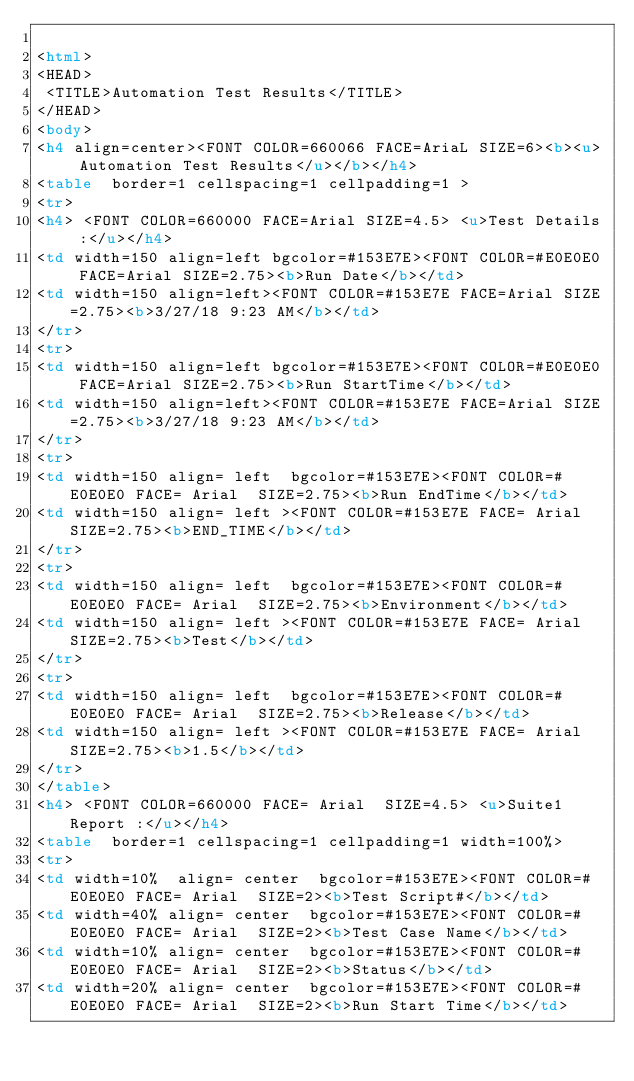Convert code to text. <code><loc_0><loc_0><loc_500><loc_500><_HTML_>
<html>
<HEAD>
 <TITLE>Automation Test Results</TITLE>
</HEAD>
<body>
<h4 align=center><FONT COLOR=660066 FACE=AriaL SIZE=6><b><u> Automation Test Results</u></b></h4>
<table  border=1 cellspacing=1 cellpadding=1 >
<tr>
<h4> <FONT COLOR=660000 FACE=Arial SIZE=4.5> <u>Test Details :</u></h4>
<td width=150 align=left bgcolor=#153E7E><FONT COLOR=#E0E0E0 FACE=Arial SIZE=2.75><b>Run Date</b></td>
<td width=150 align=left><FONT COLOR=#153E7E FACE=Arial SIZE=2.75><b>3/27/18 9:23 AM</b></td>
</tr>
<tr>
<td width=150 align=left bgcolor=#153E7E><FONT COLOR=#E0E0E0 FACE=Arial SIZE=2.75><b>Run StartTime</b></td>
<td width=150 align=left><FONT COLOR=#153E7E FACE=Arial SIZE=2.75><b>3/27/18 9:23 AM</b></td>
</tr>
<tr>
<td width=150 align= left  bgcolor=#153E7E><FONT COLOR=#E0E0E0 FACE= Arial  SIZE=2.75><b>Run EndTime</b></td>
<td width=150 align= left ><FONT COLOR=#153E7E FACE= Arial  SIZE=2.75><b>END_TIME</b></td>
</tr>
<tr>
<td width=150 align= left  bgcolor=#153E7E><FONT COLOR=#E0E0E0 FACE= Arial  SIZE=2.75><b>Environment</b></td>
<td width=150 align= left ><FONT COLOR=#153E7E FACE= Arial  SIZE=2.75><b>Test</b></td>
</tr>
<tr>
<td width=150 align= left  bgcolor=#153E7E><FONT COLOR=#E0E0E0 FACE= Arial  SIZE=2.75><b>Release</b></td>
<td width=150 align= left ><FONT COLOR=#153E7E FACE= Arial  SIZE=2.75><b>1.5</b></td>
</tr>
</table>
<h4> <FONT COLOR=660000 FACE= Arial  SIZE=4.5> <u>Suite1 Report :</u></h4>
<table  border=1 cellspacing=1 cellpadding=1 width=100%>
<tr>
<td width=10%  align= center  bgcolor=#153E7E><FONT COLOR=#E0E0E0 FACE= Arial  SIZE=2><b>Test Script#</b></td>
<td width=40% align= center  bgcolor=#153E7E><FONT COLOR=#E0E0E0 FACE= Arial  SIZE=2><b>Test Case Name</b></td>
<td width=10% align= center  bgcolor=#153E7E><FONT COLOR=#E0E0E0 FACE= Arial  SIZE=2><b>Status</b></td>
<td width=20% align= center  bgcolor=#153E7E><FONT COLOR=#E0E0E0 FACE= Arial  SIZE=2><b>Run Start Time</b></td></code> 